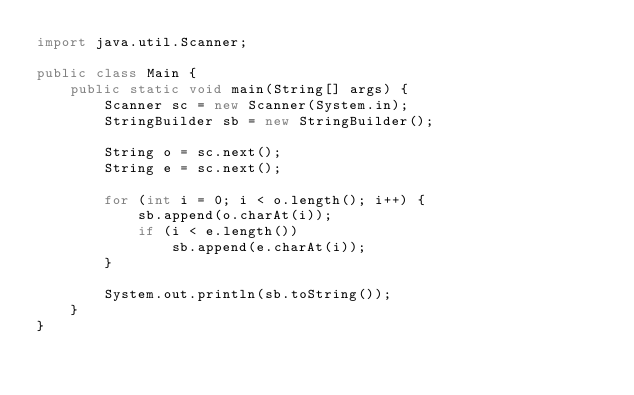Convert code to text. <code><loc_0><loc_0><loc_500><loc_500><_Java_>import java.util.Scanner;

public class Main {
    public static void main(String[] args) {
        Scanner sc = new Scanner(System.in);
        StringBuilder sb = new StringBuilder();

        String o = sc.next();
        String e = sc.next();
        
        for (int i = 0; i < o.length(); i++) {
            sb.append(o.charAt(i));
            if (i < e.length())
                sb.append(e.charAt(i));
        }
        
        System.out.println(sb.toString());
    }
}
</code> 